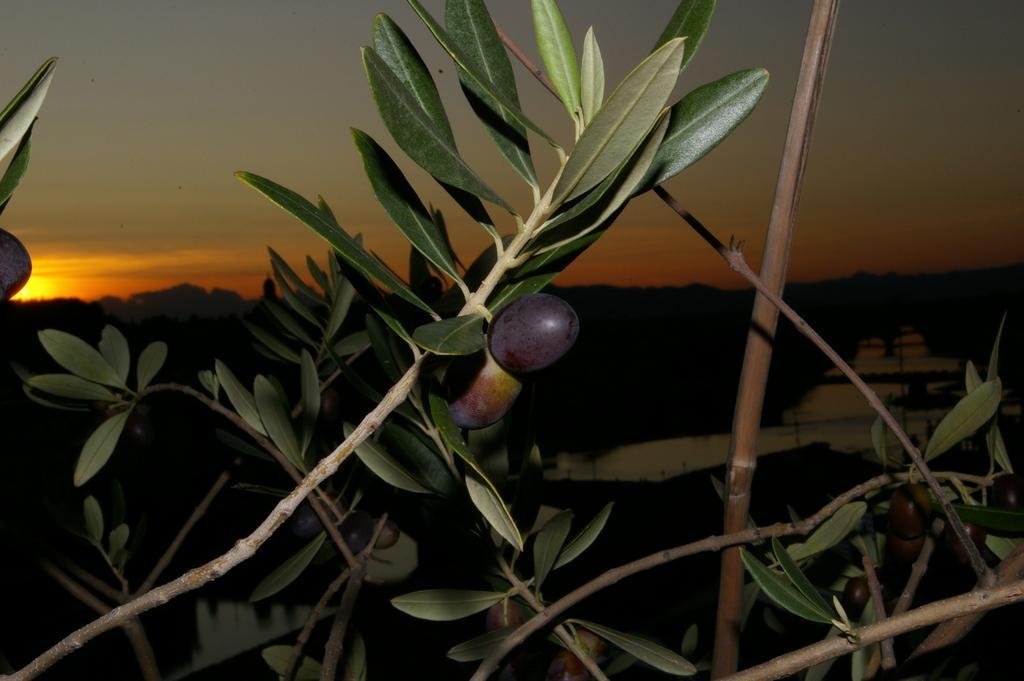Could you give a brief overview of what you see in this image? In the center of the image we can see branches with leaves and fruits. In the background, we can see the sky. And at the bottom of the sky, we can see the dark background. 